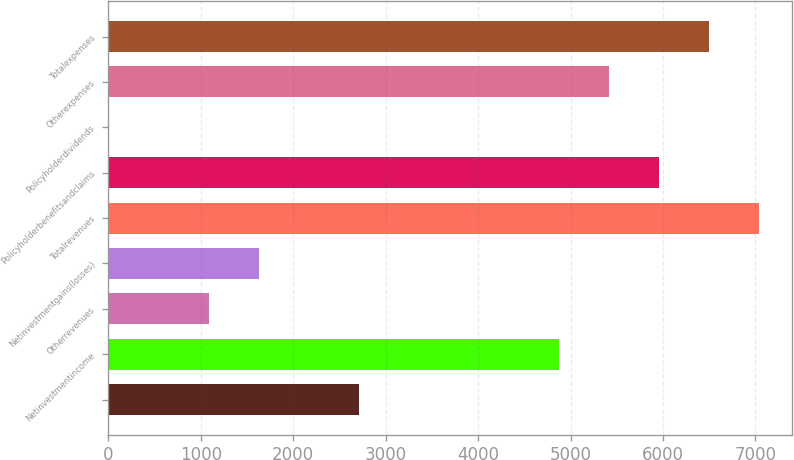<chart> <loc_0><loc_0><loc_500><loc_500><bar_chart><ecel><fcel>Netinvestmentincome<fcel>Otherrevenues<fcel>Netinvestmentgains(losses)<fcel>Totalrevenues<fcel>Policyholderbenefitsandclaims<fcel>Policyholderdividends<fcel>Otherexpenses<fcel>Totalexpenses<nl><fcel>2710.5<fcel>4875.7<fcel>1086.6<fcel>1627.9<fcel>7040.9<fcel>5958.3<fcel>4<fcel>5417<fcel>6499.6<nl></chart> 